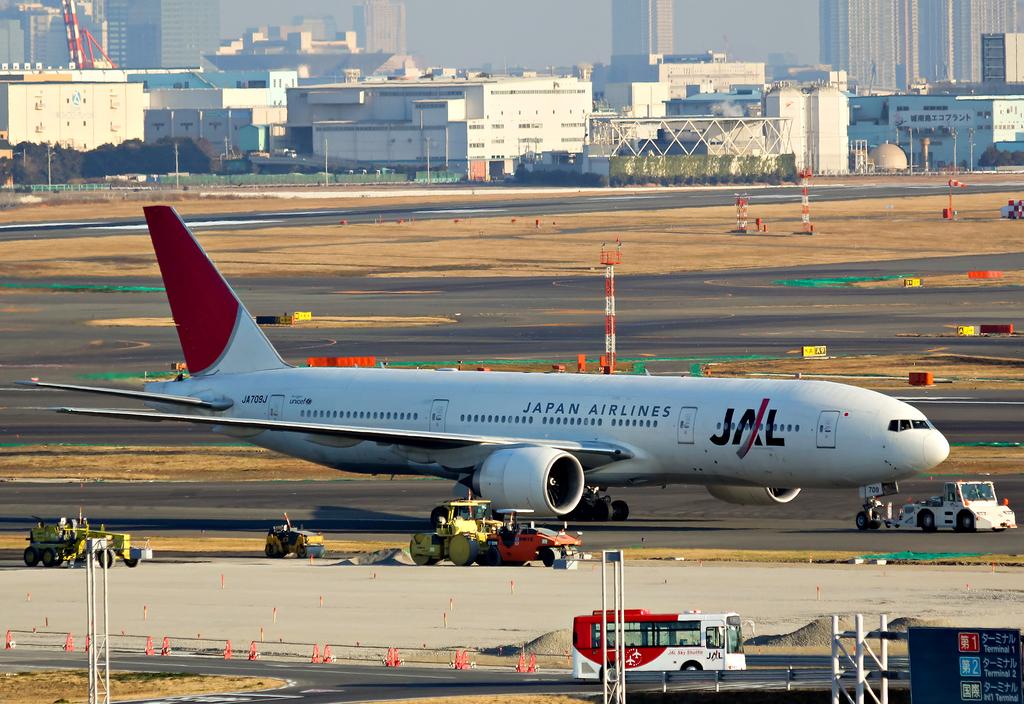What country do these airplanes come from?
Provide a short and direct response. Japan. 